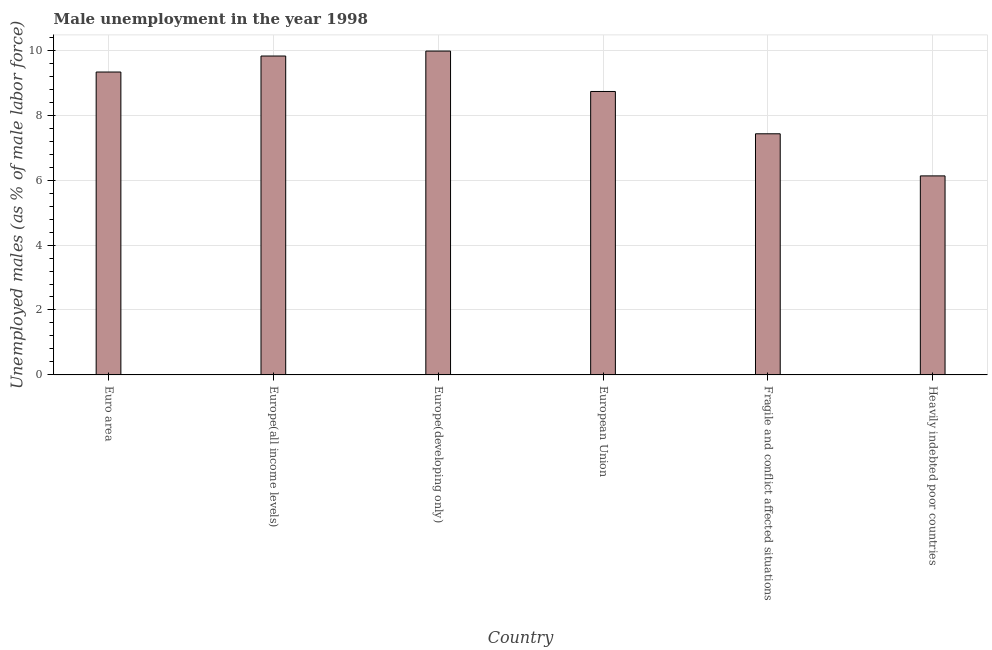Does the graph contain grids?
Ensure brevity in your answer.  Yes. What is the title of the graph?
Provide a succinct answer. Male unemployment in the year 1998. What is the label or title of the Y-axis?
Your answer should be compact. Unemployed males (as % of male labor force). What is the unemployed males population in European Union?
Provide a short and direct response. 8.73. Across all countries, what is the maximum unemployed males population?
Keep it short and to the point. 9.98. Across all countries, what is the minimum unemployed males population?
Give a very brief answer. 6.13. In which country was the unemployed males population maximum?
Provide a short and direct response. Europe(developing only). In which country was the unemployed males population minimum?
Keep it short and to the point. Heavily indebted poor countries. What is the sum of the unemployed males population?
Give a very brief answer. 51.41. What is the difference between the unemployed males population in European Union and Heavily indebted poor countries?
Your response must be concise. 2.6. What is the average unemployed males population per country?
Give a very brief answer. 8.57. What is the median unemployed males population?
Provide a succinct answer. 9.03. What is the ratio of the unemployed males population in Europe(developing only) to that in European Union?
Your response must be concise. 1.14. Is the unemployed males population in Euro area less than that in Fragile and conflict affected situations?
Your answer should be compact. No. Is the difference between the unemployed males population in Europe(all income levels) and Heavily indebted poor countries greater than the difference between any two countries?
Your answer should be compact. No. What is the difference between the highest and the second highest unemployed males population?
Provide a short and direct response. 0.15. Is the sum of the unemployed males population in Euro area and Heavily indebted poor countries greater than the maximum unemployed males population across all countries?
Give a very brief answer. Yes. What is the difference between the highest and the lowest unemployed males population?
Make the answer very short. 3.84. What is the Unemployed males (as % of male labor force) in Euro area?
Ensure brevity in your answer.  9.33. What is the Unemployed males (as % of male labor force) of Europe(all income levels)?
Your answer should be very brief. 9.82. What is the Unemployed males (as % of male labor force) in Europe(developing only)?
Your answer should be compact. 9.98. What is the Unemployed males (as % of male labor force) in European Union?
Keep it short and to the point. 8.73. What is the Unemployed males (as % of male labor force) of Fragile and conflict affected situations?
Provide a short and direct response. 7.43. What is the Unemployed males (as % of male labor force) in Heavily indebted poor countries?
Provide a short and direct response. 6.13. What is the difference between the Unemployed males (as % of male labor force) in Euro area and Europe(all income levels)?
Provide a short and direct response. -0.49. What is the difference between the Unemployed males (as % of male labor force) in Euro area and Europe(developing only)?
Offer a very short reply. -0.65. What is the difference between the Unemployed males (as % of male labor force) in Euro area and European Union?
Make the answer very short. 0.6. What is the difference between the Unemployed males (as % of male labor force) in Euro area and Fragile and conflict affected situations?
Offer a very short reply. 1.9. What is the difference between the Unemployed males (as % of male labor force) in Euro area and Heavily indebted poor countries?
Ensure brevity in your answer.  3.2. What is the difference between the Unemployed males (as % of male labor force) in Europe(all income levels) and Europe(developing only)?
Offer a terse response. -0.15. What is the difference between the Unemployed males (as % of male labor force) in Europe(all income levels) and European Union?
Make the answer very short. 1.09. What is the difference between the Unemployed males (as % of male labor force) in Europe(all income levels) and Fragile and conflict affected situations?
Your response must be concise. 2.4. What is the difference between the Unemployed males (as % of male labor force) in Europe(all income levels) and Heavily indebted poor countries?
Offer a terse response. 3.69. What is the difference between the Unemployed males (as % of male labor force) in Europe(developing only) and European Union?
Make the answer very short. 1.24. What is the difference between the Unemployed males (as % of male labor force) in Europe(developing only) and Fragile and conflict affected situations?
Make the answer very short. 2.55. What is the difference between the Unemployed males (as % of male labor force) in Europe(developing only) and Heavily indebted poor countries?
Give a very brief answer. 3.84. What is the difference between the Unemployed males (as % of male labor force) in European Union and Fragile and conflict affected situations?
Your answer should be very brief. 1.3. What is the difference between the Unemployed males (as % of male labor force) in European Union and Heavily indebted poor countries?
Offer a terse response. 2.6. What is the difference between the Unemployed males (as % of male labor force) in Fragile and conflict affected situations and Heavily indebted poor countries?
Make the answer very short. 1.3. What is the ratio of the Unemployed males (as % of male labor force) in Euro area to that in Europe(all income levels)?
Provide a succinct answer. 0.95. What is the ratio of the Unemployed males (as % of male labor force) in Euro area to that in Europe(developing only)?
Your answer should be very brief. 0.94. What is the ratio of the Unemployed males (as % of male labor force) in Euro area to that in European Union?
Your response must be concise. 1.07. What is the ratio of the Unemployed males (as % of male labor force) in Euro area to that in Fragile and conflict affected situations?
Offer a terse response. 1.26. What is the ratio of the Unemployed males (as % of male labor force) in Euro area to that in Heavily indebted poor countries?
Your answer should be very brief. 1.52. What is the ratio of the Unemployed males (as % of male labor force) in Europe(all income levels) to that in European Union?
Give a very brief answer. 1.12. What is the ratio of the Unemployed males (as % of male labor force) in Europe(all income levels) to that in Fragile and conflict affected situations?
Offer a very short reply. 1.32. What is the ratio of the Unemployed males (as % of male labor force) in Europe(all income levels) to that in Heavily indebted poor countries?
Offer a terse response. 1.6. What is the ratio of the Unemployed males (as % of male labor force) in Europe(developing only) to that in European Union?
Ensure brevity in your answer.  1.14. What is the ratio of the Unemployed males (as % of male labor force) in Europe(developing only) to that in Fragile and conflict affected situations?
Keep it short and to the point. 1.34. What is the ratio of the Unemployed males (as % of male labor force) in Europe(developing only) to that in Heavily indebted poor countries?
Provide a succinct answer. 1.63. What is the ratio of the Unemployed males (as % of male labor force) in European Union to that in Fragile and conflict affected situations?
Make the answer very short. 1.18. What is the ratio of the Unemployed males (as % of male labor force) in European Union to that in Heavily indebted poor countries?
Offer a very short reply. 1.42. What is the ratio of the Unemployed males (as % of male labor force) in Fragile and conflict affected situations to that in Heavily indebted poor countries?
Offer a terse response. 1.21. 